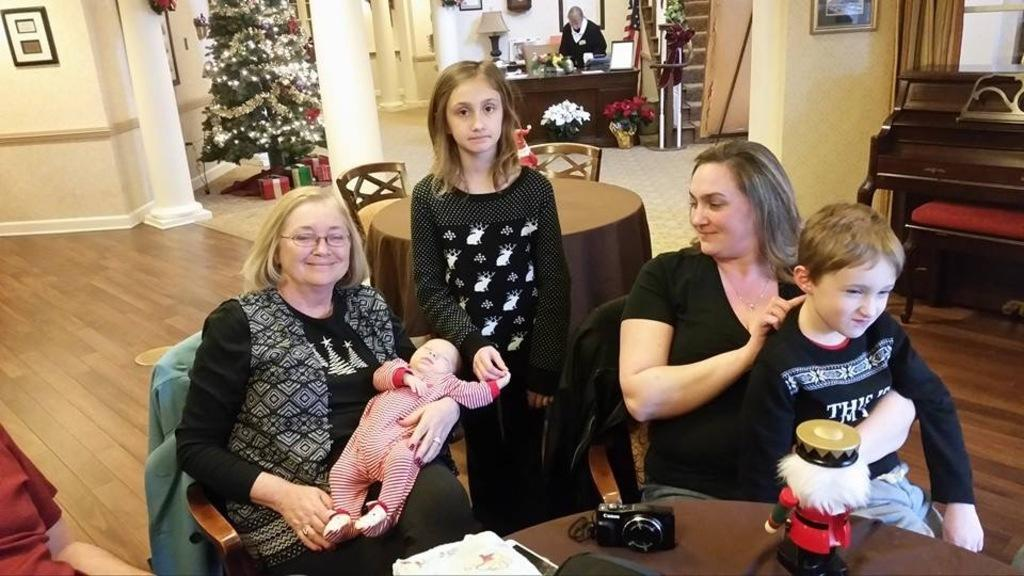What type of structure can be seen in the image? There is a wall in the image. What decorative item is present on the wall? There is a photo frame in the image. What seasonal decoration is visible in the image? There is a Christmas tree in the image. What type of lighting is present in the image? There is a lamp in the image. What type of living organisms are present in the image? There are plants and flowers in the image. What architectural feature is present in the image? There are stairs in the image. What type of furniture is present in the image? There are chairs and tables in the image. What objects are placed on the tables? There is a toy and a camera on one of the tables. What song is being sung by the representative in the image? There is no representative or song present in the image. Can you describe the stranger sitting on the chair in the image? There are no strangers present in the image; the people sitting on the chairs are not strangers. 